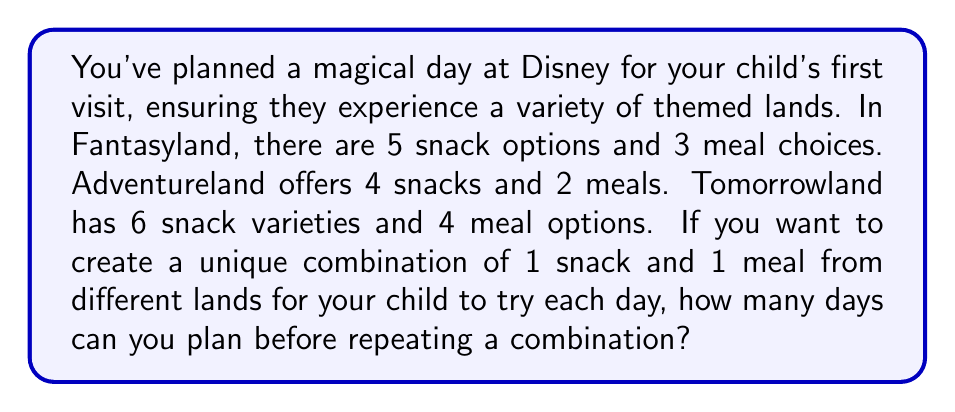Help me with this question. Let's approach this step-by-step:

1) First, we need to calculate the total number of possible combinations. We can do this by applying the multiplication principle.

2) For each day's combination, we need to choose:
   - A snack from one land
   - A meal from a different land

3) Let's count the possibilities:
   - Snack from Fantasyland (5 options) + Meal from Adventureland (2 options) or Tomorrowland (4 options): $5 \times (2 + 4) = 30$
   - Snack from Adventureland (4 options) + Meal from Fantasyland (3 options) or Tomorrowland (4 options): $4 \times (3 + 4) = 28$
   - Snack from Tomorrowland (6 options) + Meal from Fantasyland (3 options) or Adventureland (2 options): $6 \times (3 + 2) = 30$

4) The total number of unique combinations is the sum of these possibilities:

   $$ \text{Total combinations} = 30 + 28 + 30 = 88 $$

5) Each unique combination represents one day in the itinerary.

Therefore, you can plan 88 days with a unique snack and meal combination from different lands before having to repeat.
Answer: 88 days 